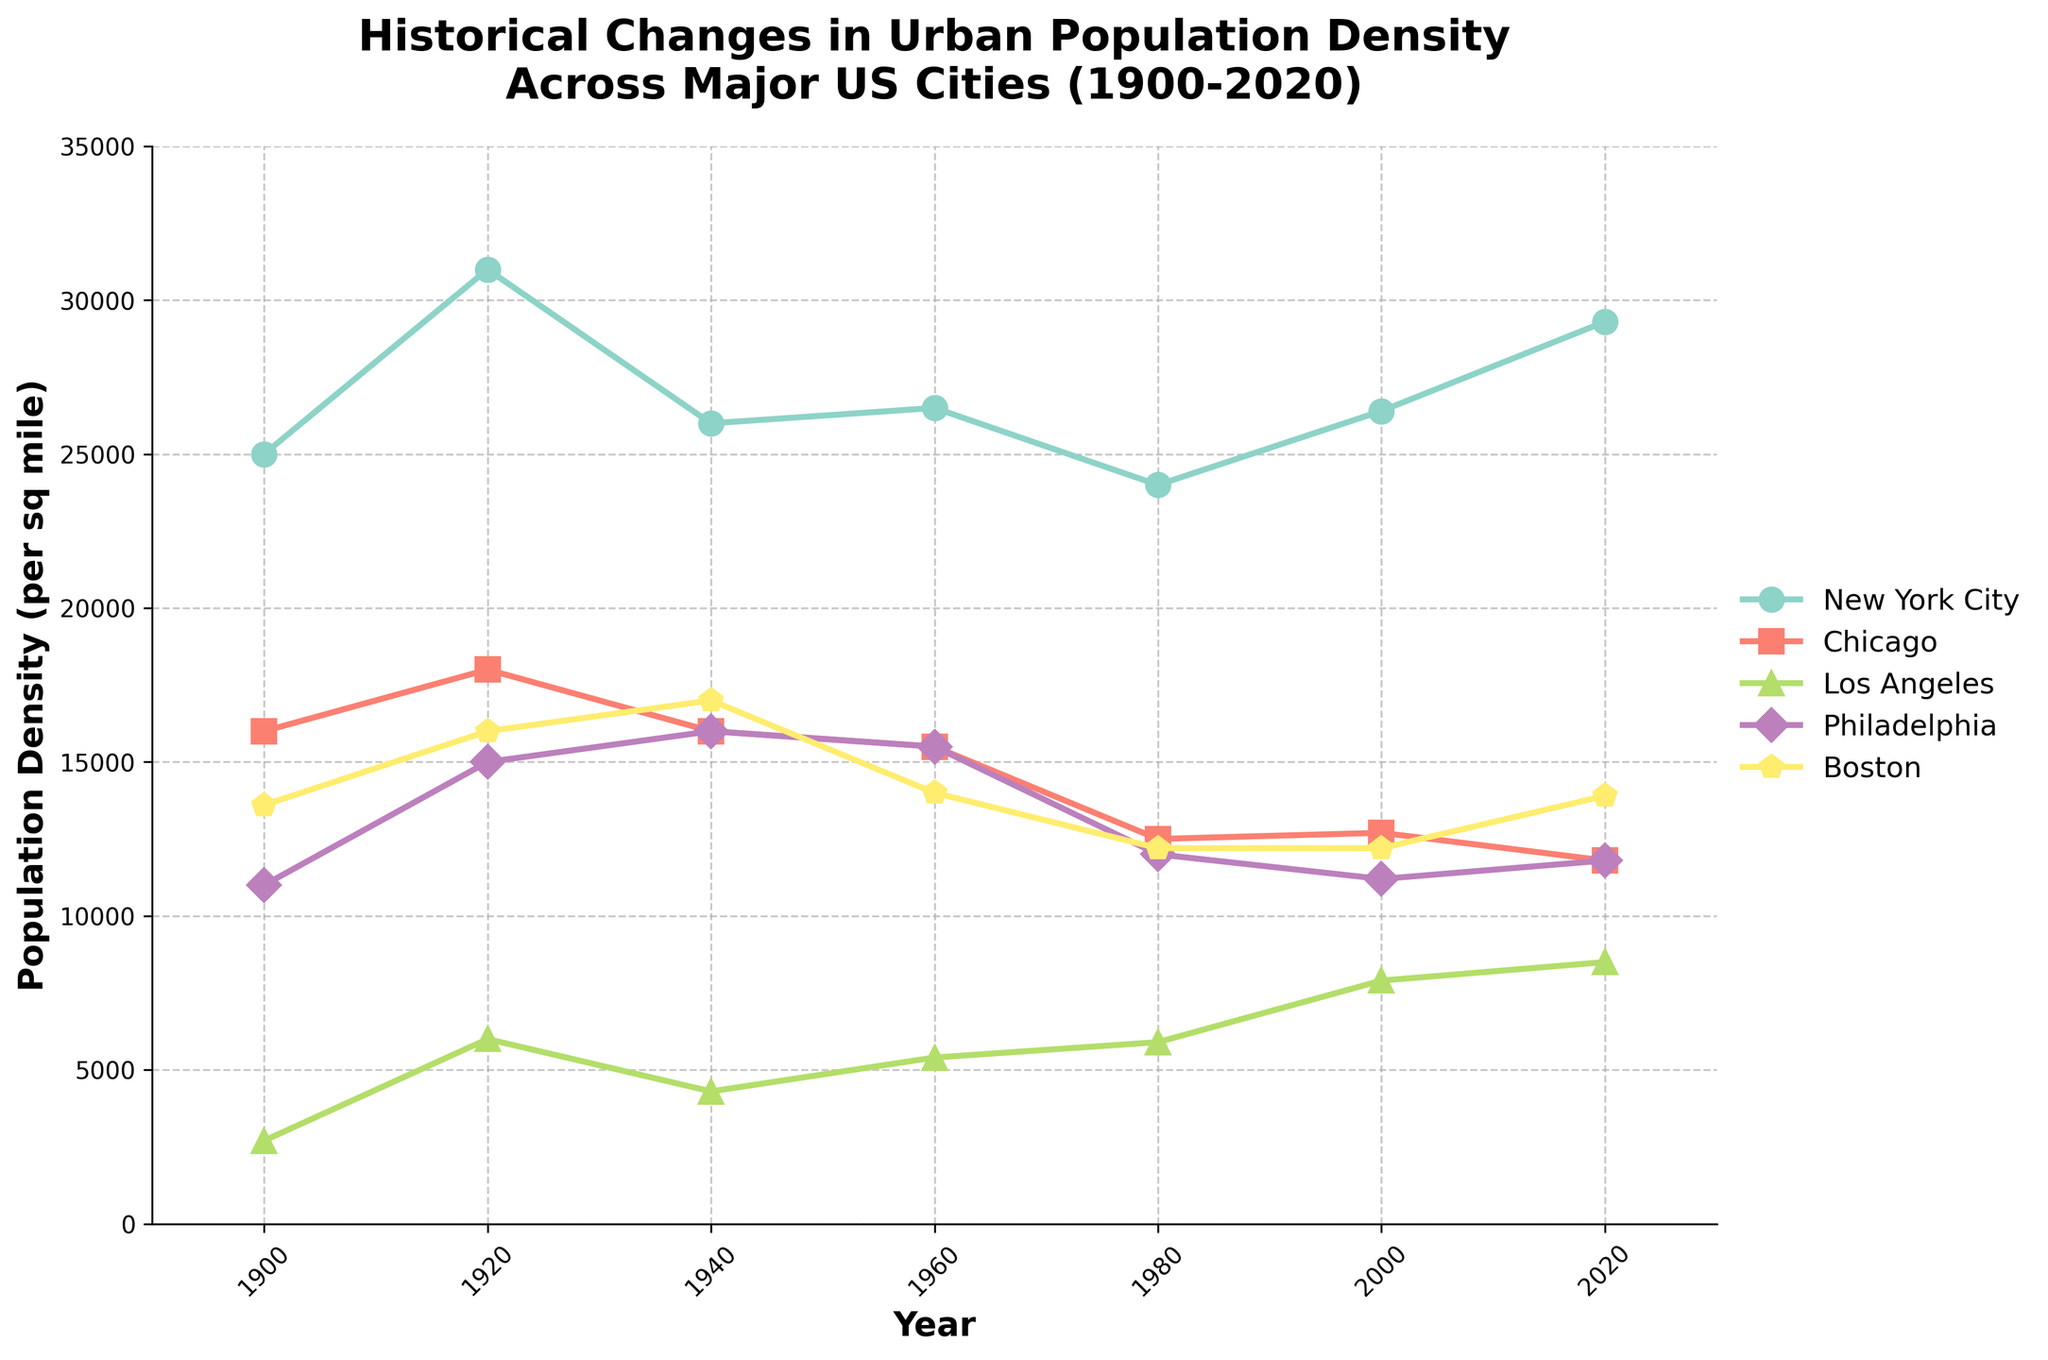Which city had the highest population density in 2020? To determine this, look at the population densities in 2020 for all the cities. Identify which city's value is the highest.
Answer: New York City How did the population density of Los Angeles compare to Chicago in 2020? Observe both Los Angeles and Chicago's population density values for 2020 and compare the numerical figures.
Answer: Los Angeles had a higher population density than Chicago in 2020 What was the population density change in Boston from 1900 to 2020? Find Boston's population density for both 1900 and 2020, then subtract the 1900 value from the 2020 value to see the change.
Answer: 300 Which two cities had the closest population densities in 1960? Examine all cities' population densities in 1960 and determine which two values are closest to each other.
Answer: Philadelphia and Chicago How did New York City's population density trend from 1900 to 2020? Look at New York City's population density points over the years and describe the overall upward or downward trend.
Answer: Upward trend Compare the general trend of Philadelphia's population density to Boston's from 1900 to 2020. Look at the overall direction of population density values for both cities from 1900 to 2020. Determine if they both generally increased, decreased, or had different patterns.
Answer: Both had fluctuating trends, with a slight decrease overall What's the average population density of Chicago between 1900 and 2020? Sum Chicago's population densities for all provided years and then divide by the number of years (6).
Answer: 14833.33 Which city had the highest drop in population density between any two consecutive recorded years? Calculate the population density differences between each consecutive year for all cities and identify the largest drop.
Answer: Chicago (1920 to 1940) How has the population density of New York City changed from 1940 to 2000? Look at New York City's population densities in 1940 and 2000, then calculate the difference between these years.
Answer: 400 Which city maintained the most stable population density trend from 1900 to 2020? Examine the population density trends for each city and identify which had the least variation over time.
Answer: New York City 